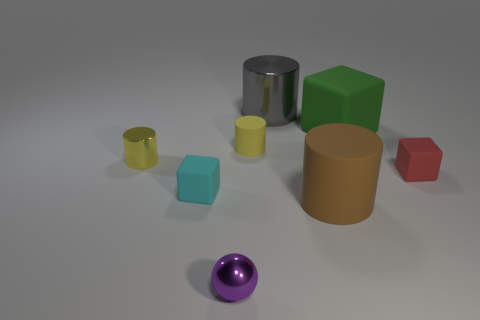Subtract all yellow metal cylinders. How many cylinders are left? 3 Add 1 tiny cyan metallic blocks. How many objects exist? 9 Subtract all yellow cylinders. How many cylinders are left? 2 Subtract 0 blue balls. How many objects are left? 8 Subtract all cubes. How many objects are left? 5 Subtract all cyan cubes. Subtract all yellow cylinders. How many cubes are left? 2 Subtract all cyan cylinders. How many red blocks are left? 1 Subtract all balls. Subtract all red objects. How many objects are left? 6 Add 3 large matte cylinders. How many large matte cylinders are left? 4 Add 7 brown rubber objects. How many brown rubber objects exist? 8 